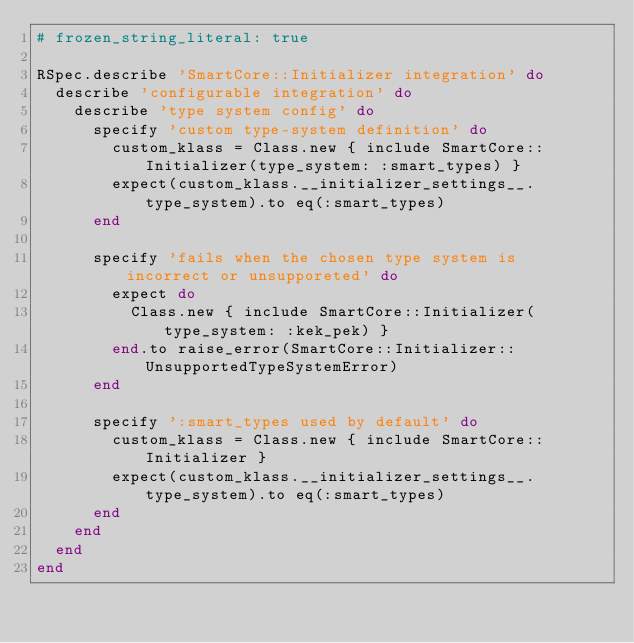<code> <loc_0><loc_0><loc_500><loc_500><_Ruby_># frozen_string_literal: true

RSpec.describe 'SmartCore::Initializer integration' do
  describe 'configurable integration' do
    describe 'type system config' do
      specify 'custom type-system definition' do
        custom_klass = Class.new { include SmartCore::Initializer(type_system: :smart_types) }
        expect(custom_klass.__initializer_settings__.type_system).to eq(:smart_types)
      end

      specify 'fails when the chosen type system is incorrect or unsupporeted' do
        expect do
          Class.new { include SmartCore::Initializer(type_system: :kek_pek) }
        end.to raise_error(SmartCore::Initializer::UnsupportedTypeSystemError)
      end

      specify ':smart_types used by default' do
        custom_klass = Class.new { include SmartCore::Initializer }
        expect(custom_klass.__initializer_settings__.type_system).to eq(:smart_types)
      end
    end
  end
end
</code> 